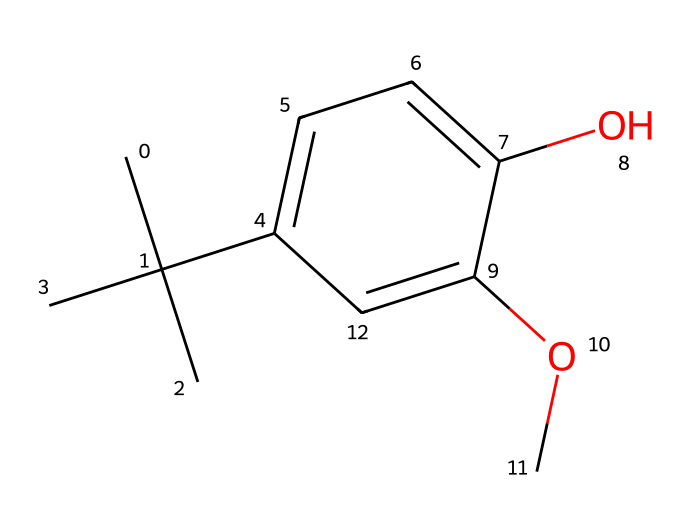What is the total number of carbon atoms in butylated hydroxyanisole? The structural formula includes several distinct carbon atoms. In the SMILES representation, there are five carbon atoms in the butyl group (C(C)(C)C) and four in the aromatic ring (c1ccc). Thus, the total is 9.
Answer: 9 How many oxygen atoms are present in the structure? The SMILES representation shows two functional groups containing oxygen: one in the hydroxy group (O) and one in the methoxy group (OC). This totals to 2 oxygen atoms.
Answer: 2 What type of functional group is present at the -OH position? The structural representation indicates the presence of a hydroxy group (-OH), as seen from the notation O attached to the aromatic ring.
Answer: hydroxy Is this compound likely to be hydrophilic or hydrophobic? The presence of both polar functional groups (hydroxy and methoxy) contributes to hydrophilicity, while the long hydrophobic alkyl chain emphasizes the overall hydrophobic character of the molecule. However, due to the non-polar portion, this compound is generally classified as hydrophobic.
Answer: hydrophobic What role does butylated hydroxyanisole serve in food products? This compound is widely used as an antioxidant preservative in food products to prevent oxidation, which keeps food fresh longer. Its chemical structure supports this property as it stabilizes free radicals.
Answer: antioxidant preservative Which part of the molecule provides its antioxidant properties? The phenolic structure, particularly the hydroxy group (-OH), can donate an electron to stabilize free radicals, giving the compound its antioxidant properties. This is crucial in preventing spoilage in food products.
Answer: phenolic structure 